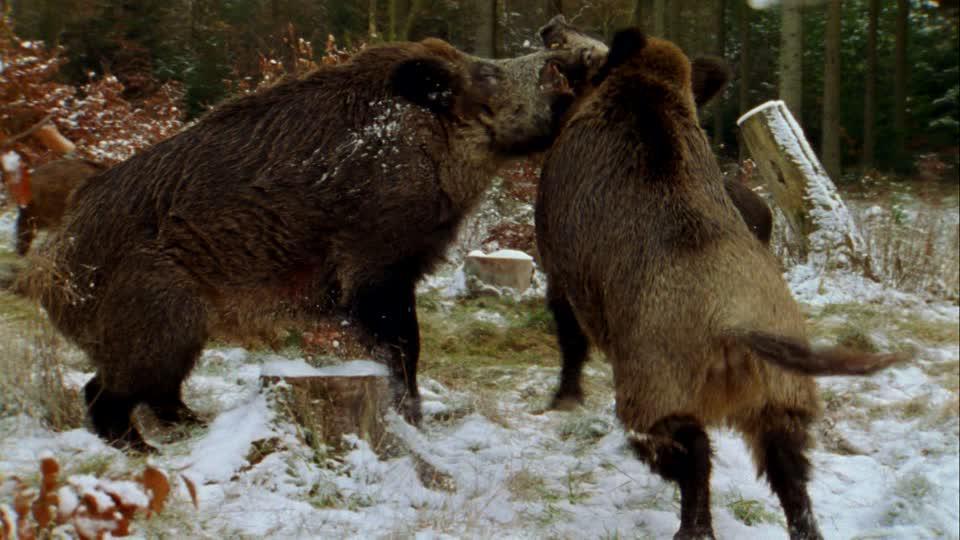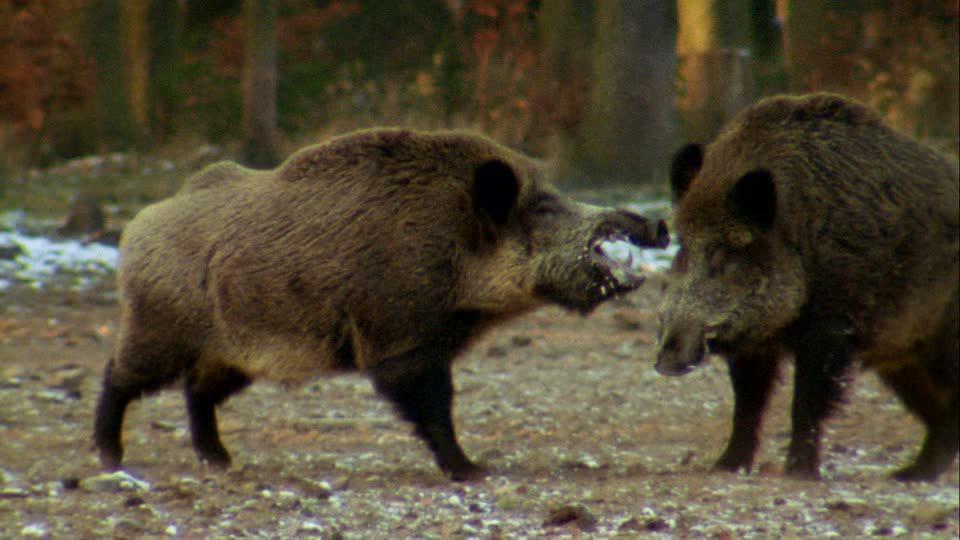The first image is the image on the left, the second image is the image on the right. For the images shown, is this caption "The right image shows at least three boars." true? Answer yes or no. No. 